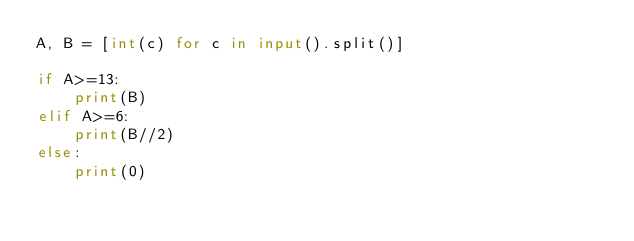Convert code to text. <code><loc_0><loc_0><loc_500><loc_500><_Python_>A, B = [int(c) for c in input().split()]

if A>=13:
    print(B)
elif A>=6:
    print(B//2)
else:
    print(0)
</code> 